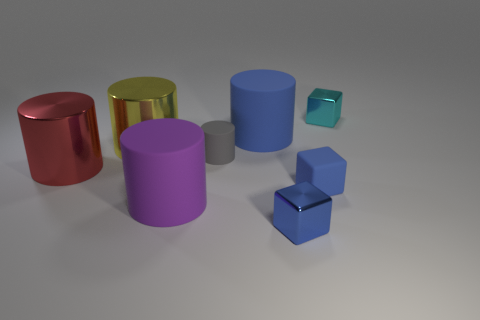There is a large matte thing that is the same color as the rubber block; what is its shape?
Make the answer very short. Cylinder. What size is the metallic block in front of the metallic block that is behind the tiny gray object?
Provide a short and direct response. Small. There is a gray object that is the same material as the purple object; what is its size?
Ensure brevity in your answer.  Small. There is a cylinder that is behind the tiny rubber block and in front of the tiny gray matte cylinder; what is its color?
Make the answer very short. Red. Are there more cylinders in front of the big red cylinder than tiny gray cubes?
Your response must be concise. Yes. Are any metal blocks visible?
Provide a short and direct response. Yes. Do the small rubber block and the tiny cylinder have the same color?
Offer a terse response. No. What number of small things are blue metal cubes or cyan cubes?
Provide a short and direct response. 2. Are there any other things that have the same color as the tiny cylinder?
Your response must be concise. No. There is a big blue thing that is made of the same material as the large purple cylinder; what is its shape?
Offer a terse response. Cylinder. 